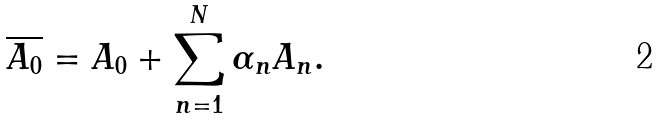Convert formula to latex. <formula><loc_0><loc_0><loc_500><loc_500>\overline { A _ { 0 } } = A _ { 0 } + \sum _ { n = 1 } ^ { N } \alpha _ { n } A _ { n } .</formula> 